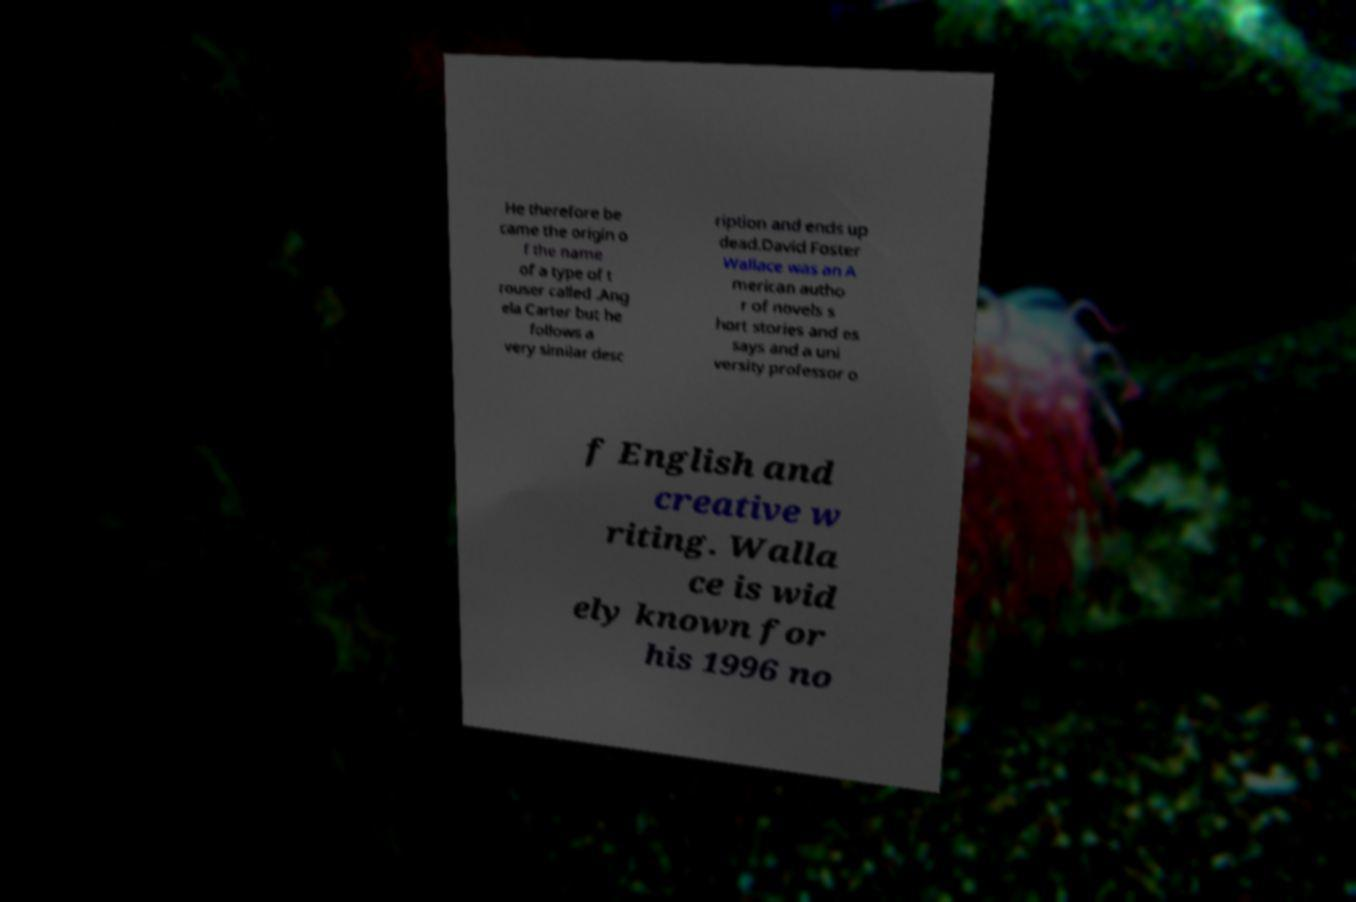Could you extract and type out the text from this image? He therefore be came the origin o f the name of a type of t rouser called .Ang ela Carter but he follows a very similar desc ription and ends up dead.David Foster Wallace was an A merican autho r of novels s hort stories and es says and a uni versity professor o f English and creative w riting. Walla ce is wid ely known for his 1996 no 